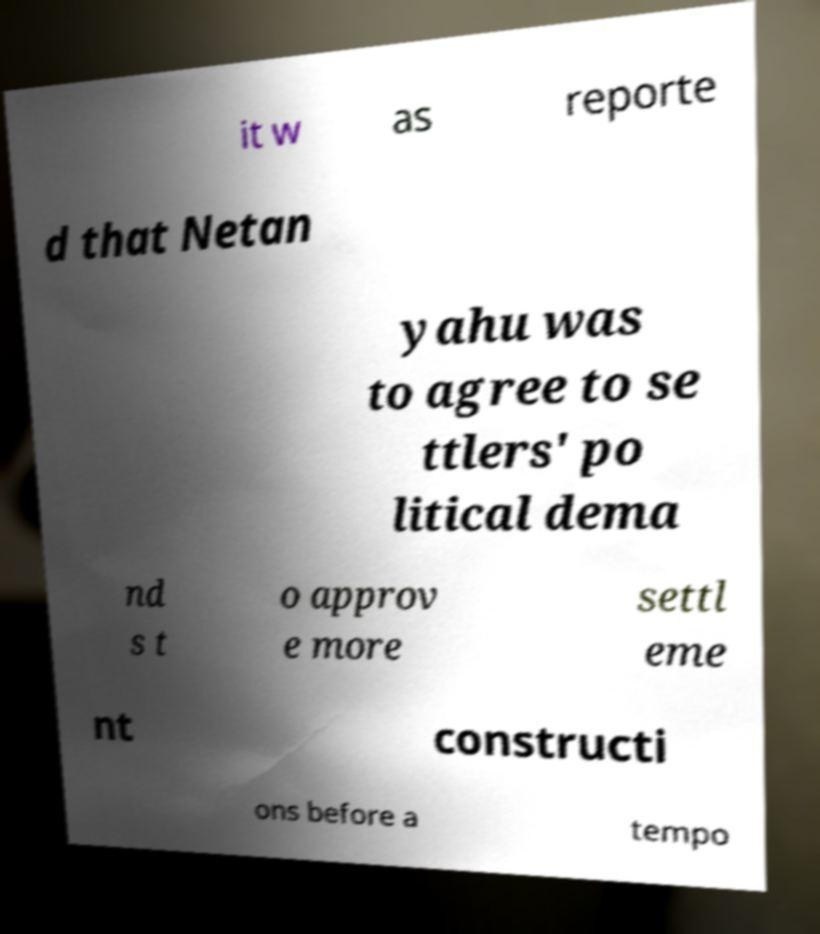Could you extract and type out the text from this image? it w as reporte d that Netan yahu was to agree to se ttlers' po litical dema nd s t o approv e more settl eme nt constructi ons before a tempo 